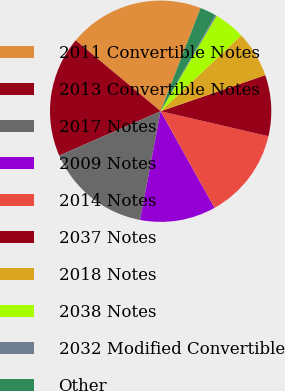Convert chart. <chart><loc_0><loc_0><loc_500><loc_500><pie_chart><fcel>2011 Convertible Notes<fcel>2013 Convertible Notes<fcel>2017 Notes<fcel>2009 Notes<fcel>2014 Notes<fcel>2037 Notes<fcel>2018 Notes<fcel>2038 Notes<fcel>2032 Modified Convertible<fcel>Other<nl><fcel>19.81%<fcel>17.63%<fcel>15.45%<fcel>11.09%<fcel>13.27%<fcel>8.91%<fcel>6.73%<fcel>4.55%<fcel>0.19%<fcel>2.37%<nl></chart> 